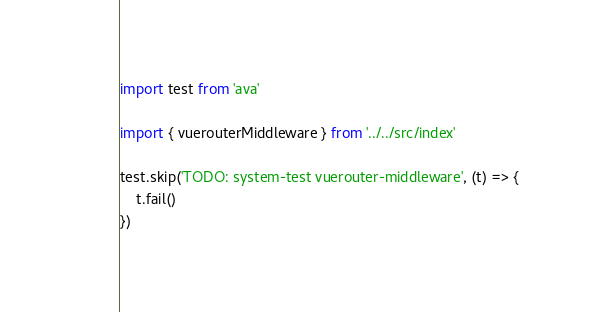<code> <loc_0><loc_0><loc_500><loc_500><_TypeScript_>import test from 'ava'

import { vuerouterMiddleware } from '../../src/index'

test.skip('TODO: system-test vuerouter-middleware', (t) => {
    t.fail()
})
</code> 